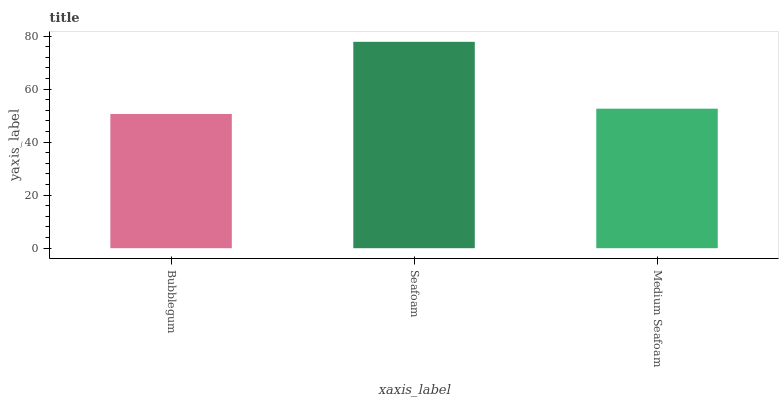Is Bubblegum the minimum?
Answer yes or no. Yes. Is Seafoam the maximum?
Answer yes or no. Yes. Is Medium Seafoam the minimum?
Answer yes or no. No. Is Medium Seafoam the maximum?
Answer yes or no. No. Is Seafoam greater than Medium Seafoam?
Answer yes or no. Yes. Is Medium Seafoam less than Seafoam?
Answer yes or no. Yes. Is Medium Seafoam greater than Seafoam?
Answer yes or no. No. Is Seafoam less than Medium Seafoam?
Answer yes or no. No. Is Medium Seafoam the high median?
Answer yes or no. Yes. Is Medium Seafoam the low median?
Answer yes or no. Yes. Is Seafoam the high median?
Answer yes or no. No. Is Bubblegum the low median?
Answer yes or no. No. 